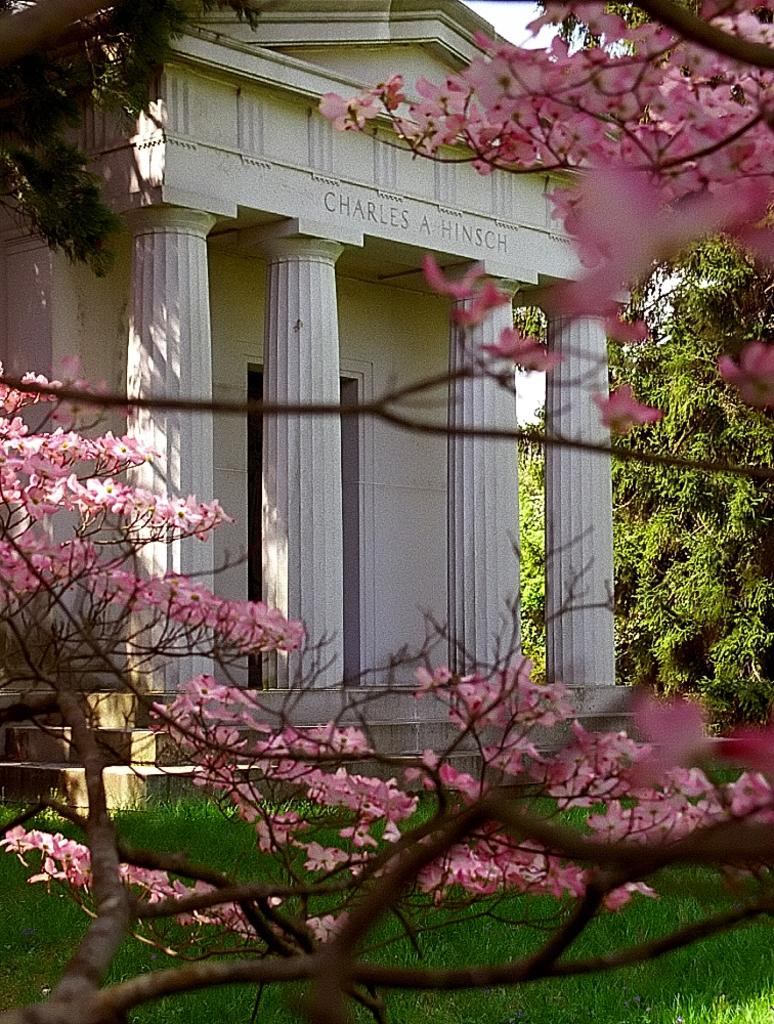What type of structure is present in the image? There is a building in the image. What other natural elements can be seen in the image? There are trees, flowers, and grass visible in the image. What is visible in the background of the image? The sky is visible in the background of the image. Where is the crib located in the image? There is no crib present in the image. What type of structure is the building in the image used for? The provided facts do not specify the purpose or function of the building in the image. 